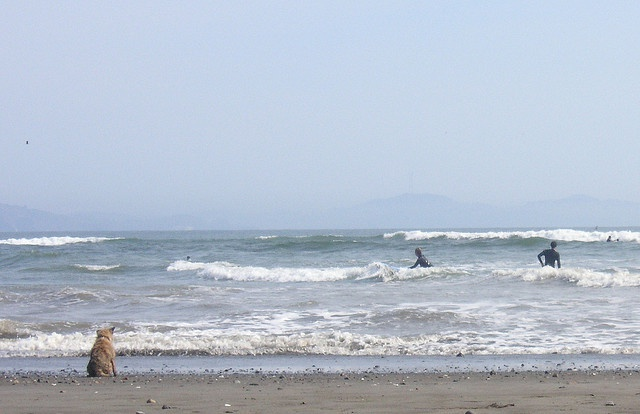Describe the objects in this image and their specific colors. I can see dog in lavender, gray, black, and tan tones, people in lavender, gray, darkblue, navy, and darkgray tones, people in lavender, gray, darkgray, and darkblue tones, and people in lavender, gray, darkgray, and lightgray tones in this image. 